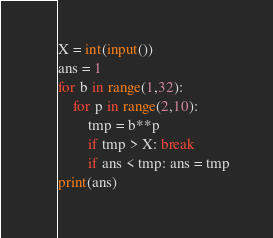Convert code to text. <code><loc_0><loc_0><loc_500><loc_500><_Python_>X = int(input())
ans = 1
for b in range(1,32):
    for p in range(2,10):
        tmp = b**p
        if tmp > X: break
        if ans < tmp: ans = tmp
print(ans)</code> 